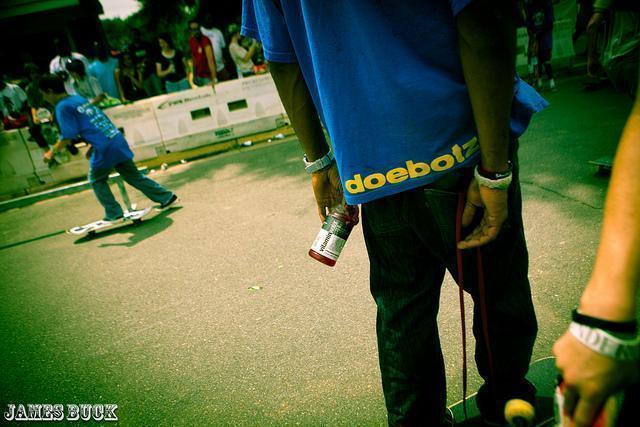What flavoured beverage is in the bottle?
From the following four choices, select the correct answer to address the question.
Options: Soda, beer, water, wine. Water. 